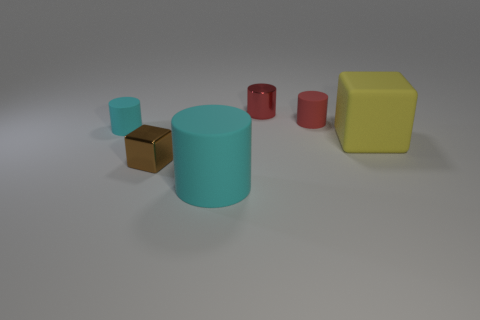Subtract all small red metal cylinders. How many cylinders are left? 3 Add 1 large yellow cubes. How many objects exist? 7 Subtract all red spheres. How many cyan cylinders are left? 2 Subtract all cyan cylinders. How many cylinders are left? 2 Add 3 large yellow cubes. How many large yellow cubes exist? 4 Subtract 1 cyan cylinders. How many objects are left? 5 Subtract all cylinders. How many objects are left? 2 Subtract 3 cylinders. How many cylinders are left? 1 Subtract all blue cylinders. Subtract all yellow cubes. How many cylinders are left? 4 Subtract all yellow objects. Subtract all gray rubber spheres. How many objects are left? 5 